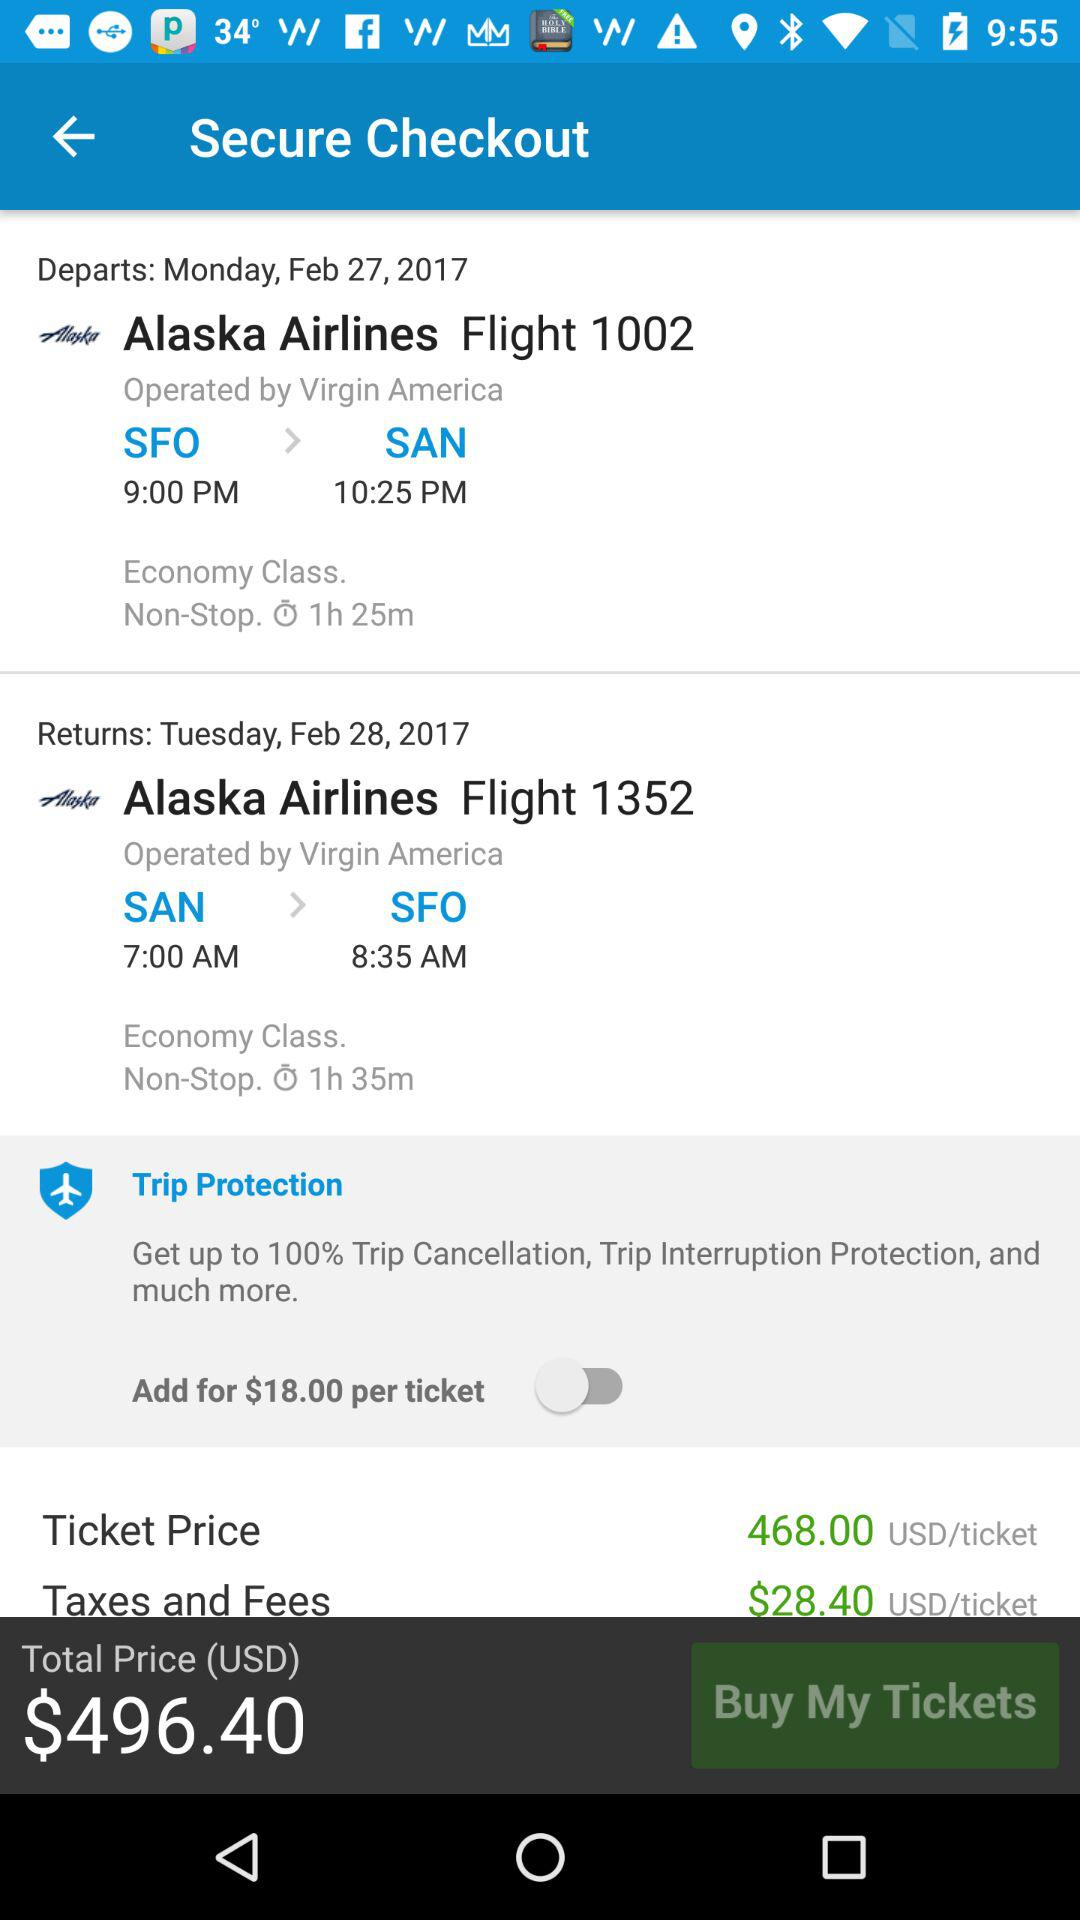What is the duration of flight 1002? The duration of flight 1002 is 1 hour and 25 minutes. 